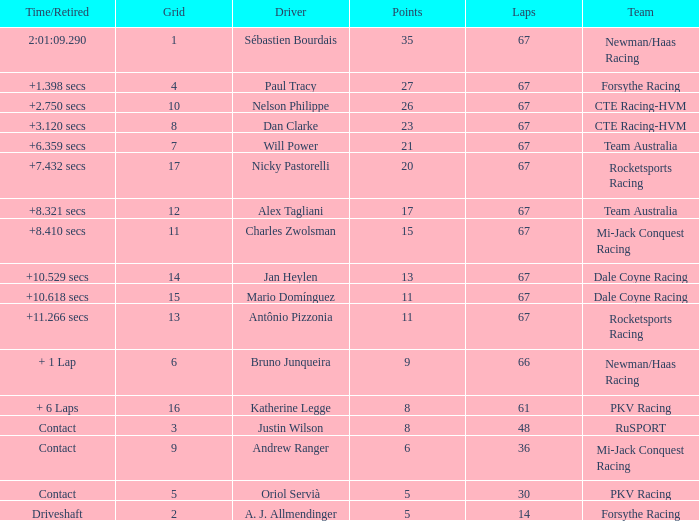How many average laps for Alex Tagliani with more than 17 points? None. 